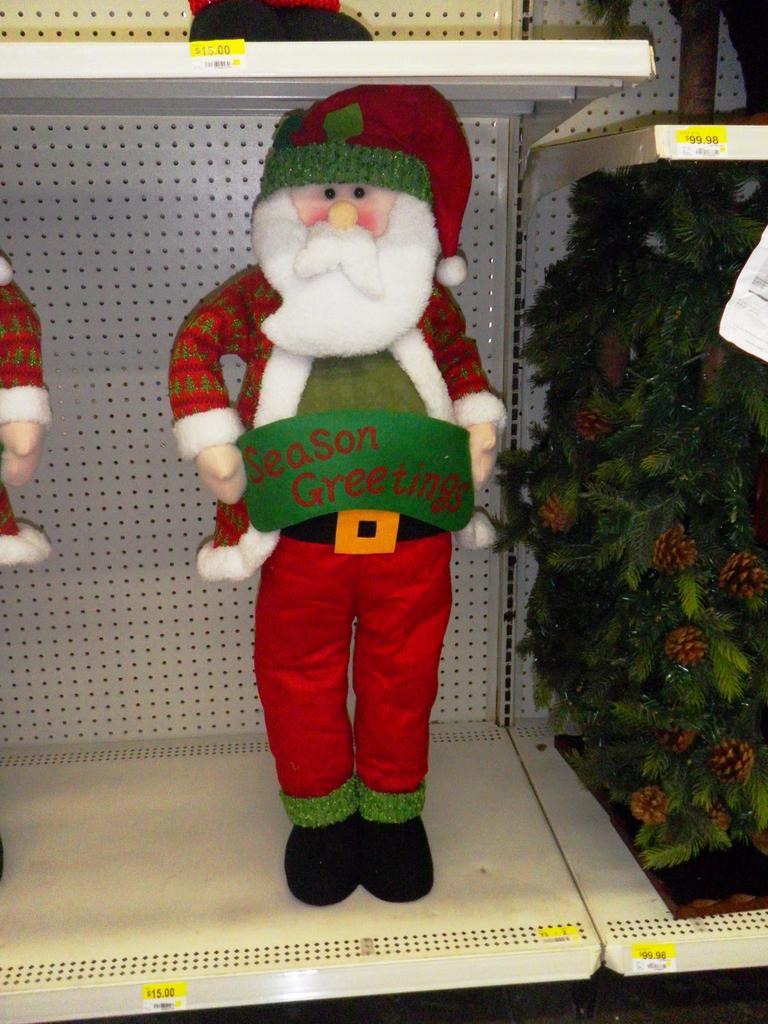What sign is this santa holding?
Your answer should be compact. Season greetings. What does this dolls banner say?
Provide a short and direct response. Season greetings. 